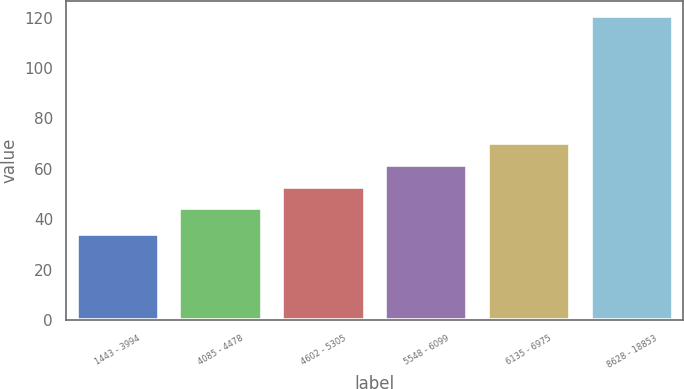Convert chart to OTSL. <chart><loc_0><loc_0><loc_500><loc_500><bar_chart><fcel>1443 - 3994<fcel>4085 - 4478<fcel>4602 - 5305<fcel>5548 - 6099<fcel>6135 - 6975<fcel>8628 - 18853<nl><fcel>34.18<fcel>44.35<fcel>52.98<fcel>61.61<fcel>70.24<fcel>120.46<nl></chart> 